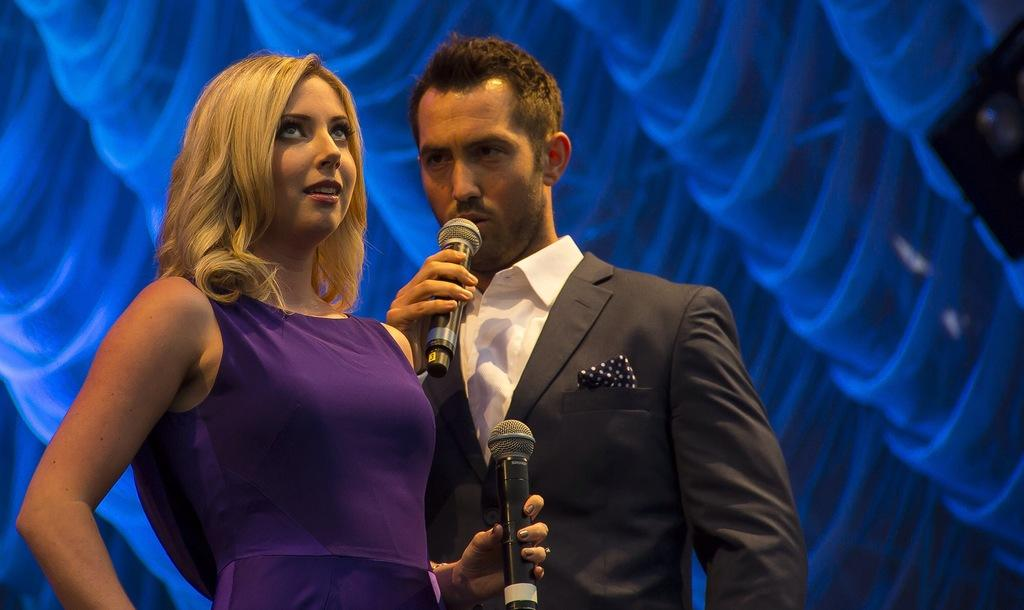Who are the people in the image? There is a woman and a man in the image. What is the man holding in his hands? The man is holding a microphone with his hands. What is the man wearing? The man is wearing a black suit. Can you see any jellyfish in the image? No, there are no jellyfish present in the image. What type of map is the man holding in the image? The man is not holding a map in the image; he is holding a microphone. 